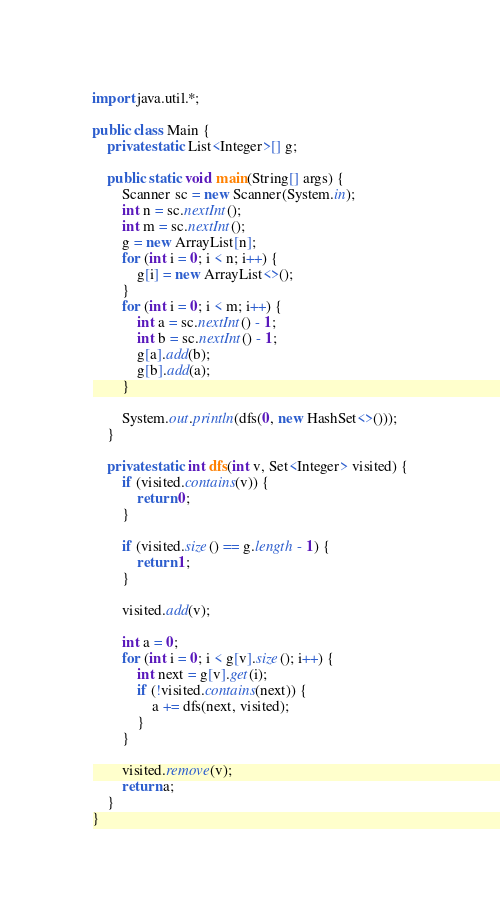Convert code to text. <code><loc_0><loc_0><loc_500><loc_500><_Java_>import java.util.*;

public class Main {
	private static List<Integer>[] g;

	public static void main(String[] args) {
		Scanner sc = new Scanner(System.in);
		int n = sc.nextInt();
		int m = sc.nextInt();
		g = new ArrayList[n];
		for (int i = 0; i < n; i++) {
			g[i] = new ArrayList<>();
		}
		for (int i = 0; i < m; i++) {
			int a = sc.nextInt() - 1;
			int b = sc.nextInt() - 1;
			g[a].add(b);
			g[b].add(a);
		}

		System.out.println(dfs(0, new HashSet<>()));
	}

	private static int dfs(int v, Set<Integer> visited) {
		if (visited.contains(v)) {
			return 0;
		}

		if (visited.size() == g.length - 1) {
			return 1;
		}

		visited.add(v);

		int a = 0;
		for (int i = 0; i < g[v].size(); i++) {
			int next = g[v].get(i);
			if (!visited.contains(next)) {
				a += dfs(next, visited);
			}
		}

		visited.remove(v);
		return a;
	}
}
</code> 